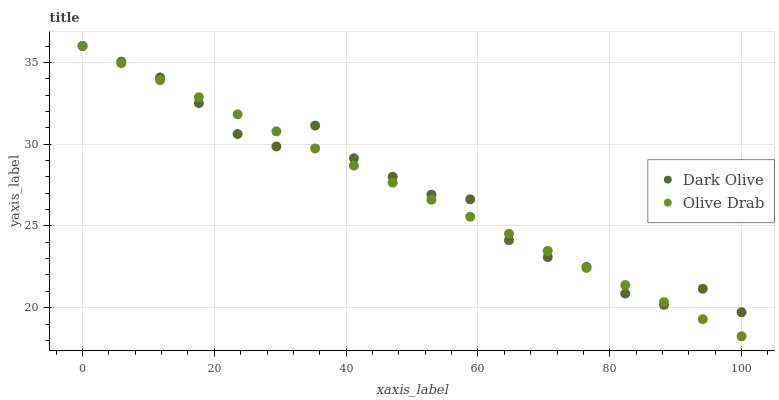Does Olive Drab have the minimum area under the curve?
Answer yes or no. Yes. Does Dark Olive have the maximum area under the curve?
Answer yes or no. Yes. Does Olive Drab have the maximum area under the curve?
Answer yes or no. No. Is Olive Drab the smoothest?
Answer yes or no. Yes. Is Dark Olive the roughest?
Answer yes or no. Yes. Is Olive Drab the roughest?
Answer yes or no. No. Does Olive Drab have the lowest value?
Answer yes or no. Yes. Does Olive Drab have the highest value?
Answer yes or no. Yes. Does Dark Olive intersect Olive Drab?
Answer yes or no. Yes. Is Dark Olive less than Olive Drab?
Answer yes or no. No. Is Dark Olive greater than Olive Drab?
Answer yes or no. No. 